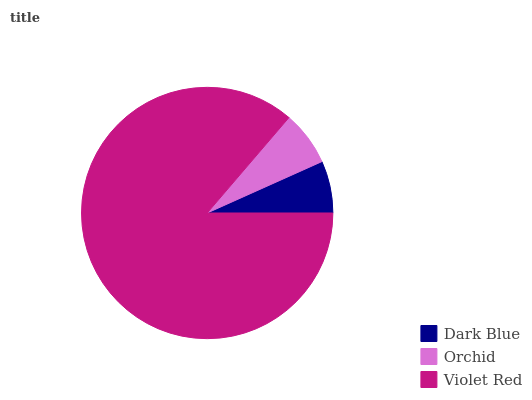Is Dark Blue the minimum?
Answer yes or no. Yes. Is Violet Red the maximum?
Answer yes or no. Yes. Is Orchid the minimum?
Answer yes or no. No. Is Orchid the maximum?
Answer yes or no. No. Is Orchid greater than Dark Blue?
Answer yes or no. Yes. Is Dark Blue less than Orchid?
Answer yes or no. Yes. Is Dark Blue greater than Orchid?
Answer yes or no. No. Is Orchid less than Dark Blue?
Answer yes or no. No. Is Orchid the high median?
Answer yes or no. Yes. Is Orchid the low median?
Answer yes or no. Yes. Is Dark Blue the high median?
Answer yes or no. No. Is Violet Red the low median?
Answer yes or no. No. 